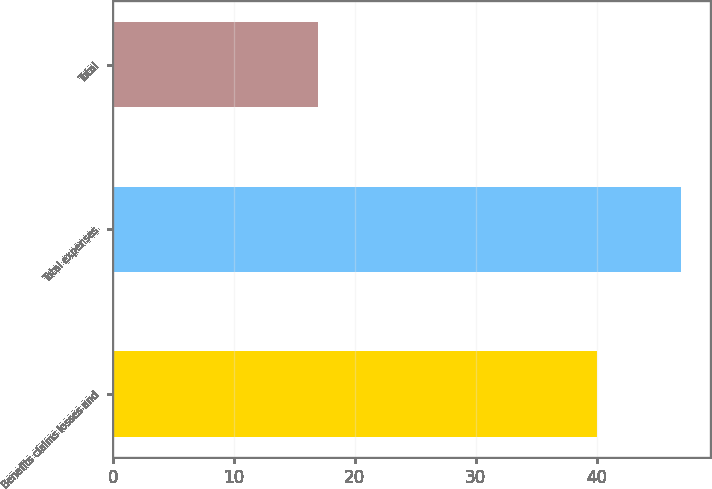Convert chart. <chart><loc_0><loc_0><loc_500><loc_500><bar_chart><fcel>Benefits claims losses and<fcel>Total expenses<fcel>Total<nl><fcel>40<fcel>47<fcel>17<nl></chart> 